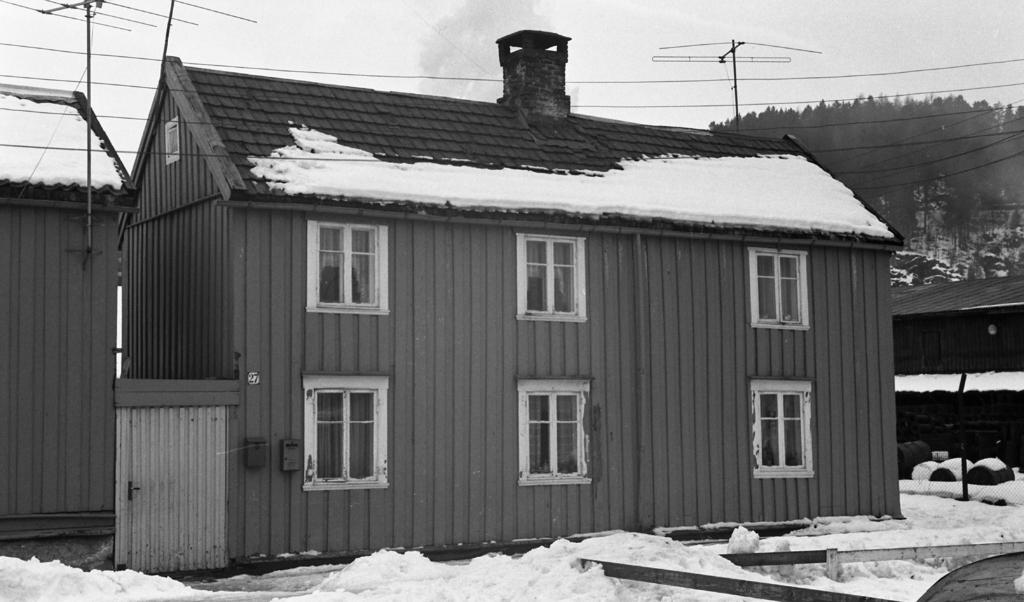What type of structure is present in the image? There is a house in the image. What is the weather like in the image? There is snow in the image, indicating a cold and likely wintery scene. What type of vegetation can be seen in the image? There are trees in the image. What else can be seen in the image besides the house and trees? Electric wires are visible in the image. What type of church can be seen in the image? There is no church present in the image; it features a house, snow, trees, and electric wires. How does the bee feel about the snow in the image? There are no bees present in the image, so it is impossible to determine how a bee might feel about the snow. 